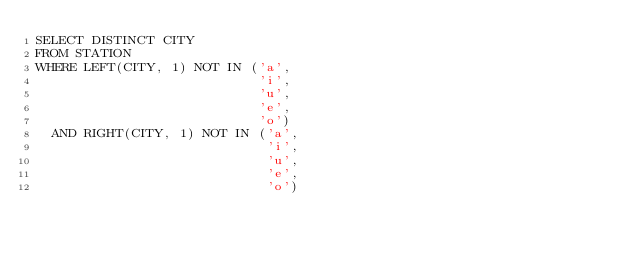Convert code to text. <code><loc_0><loc_0><loc_500><loc_500><_SQL_>SELECT DISTINCT CITY
FROM STATION
WHERE LEFT(CITY, 1) NOT IN ('a',
                            'i',
                            'u',
                            'e',
                            'o')
  AND RIGHT(CITY, 1) NOT IN ('a',
                             'i',
                             'u',
                             'e',
                             'o')
</code> 